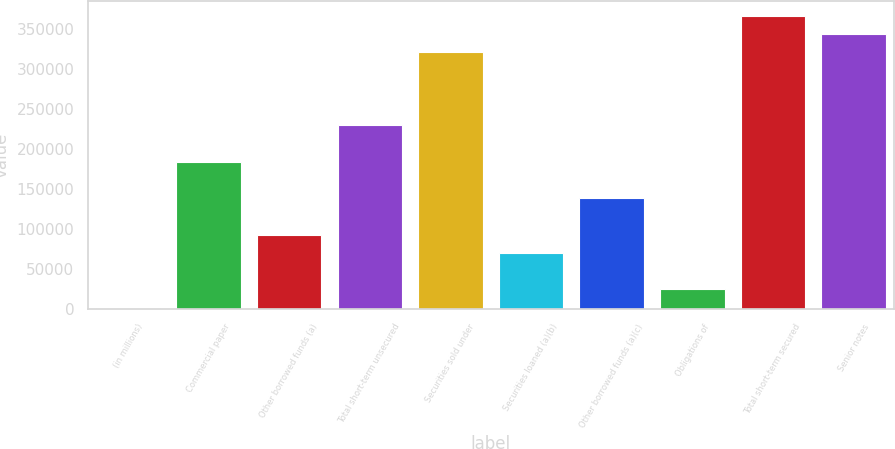Convert chart. <chart><loc_0><loc_0><loc_500><loc_500><bar_chart><fcel>(in millions)<fcel>Commercial paper<fcel>Other borrowed funds (a)<fcel>Total short-term unsecured<fcel>Securities sold under<fcel>Securities loaned (a)(b)<fcel>Other borrowed funds (a)(c)<fcel>Obligations of<fcel>Total short-term secured<fcel>Senior notes<nl><fcel>2017<fcel>184103<fcel>93060.2<fcel>229625<fcel>320668<fcel>70299.4<fcel>138582<fcel>24777.8<fcel>366190<fcel>343429<nl></chart> 